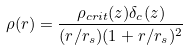<formula> <loc_0><loc_0><loc_500><loc_500>\rho ( r ) = \frac { \rho _ { c r i t } ( z ) \delta _ { c } ( z ) } { ( r / r _ { s } ) ( 1 + r / r _ { s } ) ^ { 2 } }</formula> 